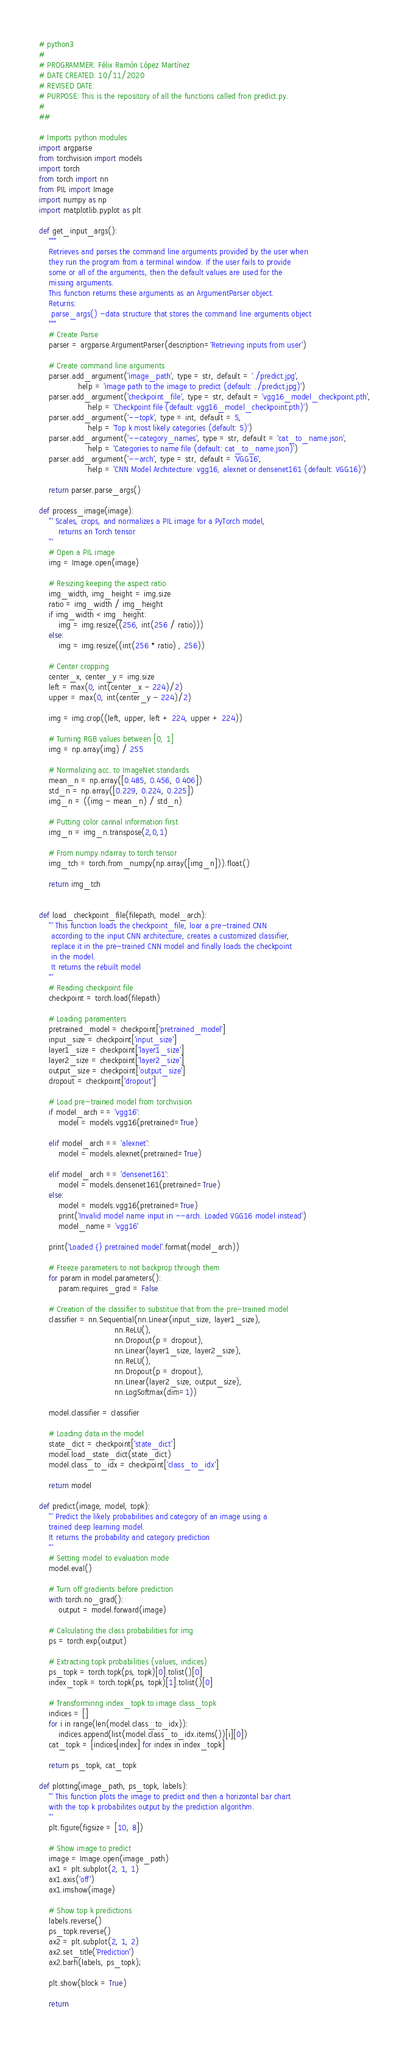Convert code to text. <code><loc_0><loc_0><loc_500><loc_500><_Python_># python3
#
# PROGRAMMER: Félix Ramón López Martínez
# DATE CREATED: 10/11/2020
# REVISED DATE:
# PURPOSE: This is the repository of all the functions called fron predict.py.
#
##

# Imports python modules
import argparse
from torchvision import models
import torch
from torch import nn
from PIL import Image
import numpy as np
import matplotlib.pyplot as plt

def get_input_args():
    """
    Retrieves and parses the command line arguments provided by the user when
    they run the program from a terminal window. If the user fails to provide
    some or all of the arguments, then the default values are used for the
    missing arguments.
    This function returns these arguments as an ArgumentParser object.
    Returns:
     parse_args() -data structure that stores the command line arguments object
    """
    # Create Parse
    parser = argparse.ArgumentParser(description='Retrieving inputs from user')

    # Create command line arguments
    parser.add_argument('image_path', type = str, default = './predict.jpg',
                help = 'image path to the image to predict (default: ./predict.jpg)')
    parser.add_argument('checkpoint_file', type = str, default = 'vgg16_model_checkpoint.pth',
                    help = 'Checkpoint file (default: vgg16_model_checkpoint.pth)')
    parser.add_argument('--topk', type = int, default = 5,
                    help = 'Top k most likely categories (default: 5)')
    parser.add_argument('--category_names', type = str, default = 'cat_to_name.json',
                    help = 'Categories to name file (default: cat_to_name.json)')
    parser.add_argument('--arch', type = str, default = 'VGG16',
                    help = 'CNN Model Architecture: vgg16, alexnet or densenet161 (default: VGG16)')

    return parser.parse_args()

def process_image(image):
    ''' Scales, crops, and normalizes a PIL image for a PyTorch model,
        returns an Torch tensor
    '''
    # Open a PIL image
    img = Image.open(image)

    # Resizing keeping the aspect ratio
    img_width, img_height = img.size
    ratio = img_width / img_height
    if img_width < img_height:
        img = img.resize((256, int(256 / ratio)))
    else:
        img = img.resize((int(256 * ratio) , 256))

    # Center cropping
    center_x, center_y = img.size
    left = max(0, int(center_x - 224)/2)
    upper = max(0, int(center_y - 224)/2)

    img = img.crop((left, upper, left + 224, upper + 224))

    # Turning RGB values between [0, 1]
    img = np.array(img) / 255

    # Normalizing acc. to ImageNet standards
    mean_n = np.array([0.485, 0.456, 0.406])
    std_n = np.array([0.229, 0.224, 0.225])
    img_n = ((img - mean_n) / std_n)

    # Putting color cannal information first
    img_n = img_n.transpose(2,0,1)

    # From numpy ndarray to torch tensor
    img_tch = torch.from_numpy(np.array([img_n])).float()

    return img_tch


def load_checkpoint_file(filepath, model_arch):
    ''' This function loads the checkpoint_file, loar a pre-trained CNN
     according to the input CNN architecture, creates a customized classifier,
     replace it in the pre-trained CNN model and finally loads the checkpoint
     in the model.
     It returns the rebuilt model
    '''
    # Reading checkpoint file
    checkpoint = torch.load(filepath)

    # Loading paramenters
    pretrained_model = checkpoint['pretrained_model']
    input_size = checkpoint['input_size']
    layer1_size = checkpoint['layer1_size']
    layer2_size = checkpoint['layer2_size']
    output_size = checkpoint['output_size']
    dropout = checkpoint['dropout']

    # Load pre-trained model from torchvision
    if model_arch == 'vgg16':
        model = models.vgg16(pretrained=True)

    elif model_arch == 'alexnet':
        model = models.alexnet(pretrained=True)

    elif model_arch == 'densenet161':
        model = models.densenet161(pretrained=True)
    else:
        model = models.vgg16(pretrained=True)
        print('Invalid model name input in --arch. Loaded VGG16 model instead')
        model_name = 'vgg16'

    print('Loaded {} pretrained model'.format(model_arch))

    # Freeze parameters to not backprop through them
    for param in model.parameters():
        param.requires_grad = False

    # Creation of the classifier to substitue that from the pre-trained model
    classifier = nn.Sequential(nn.Linear(input_size, layer1_size),
                               nn.ReLU(),
                               nn.Dropout(p = dropout),
                               nn.Linear(layer1_size, layer2_size),
                               nn.ReLU(),
                               nn.Dropout(p = dropout),
                               nn.Linear(layer2_size, output_size),
                               nn.LogSoftmax(dim=1))

    model.classifier = classifier

    # Loading data in the model
    state_dict = checkpoint['state_dict']
    model.load_state_dict(state_dict)
    model.class_to_idx = checkpoint['class_to_idx']

    return model

def predict(image, model, topk):
    ''' Predict the likely probabilities and category of an image using a
    trained deep learning model.
    It returns the probability and category prediction
    '''
    # Setting model to evaluation mode
    model.eval()

    # Turn off gradients before prediction
    with torch.no_grad():
        output = model.forward(image)

    # Calculating the class probabilities for img
    ps = torch.exp(output)

    # Extracting topk probabilities (values, indices)
    ps_topk = torch.topk(ps, topk)[0].tolist()[0]
    index_topk = torch.topk(ps, topk)[1].tolist()[0]

    # Transforminng index_topk to image class_topk
    indices = []
    for i in range(len(model.class_to_idx)):
        indices.append(list(model.class_to_idx.items())[i][0])
    cat_topk = [indices[index] for index in index_topk]

    return ps_topk, cat_topk

def plotting(image_path, ps_topk, labels):
    ''' This function plots the image to predict and then a horizontal bar chart
    with the top k probabilites output by the prediction algorithm.
    '''
    plt.figure(figsize = [10, 8])

    # Show image to predict
    image = Image.open(image_path)
    ax1 = plt.subplot(2, 1, 1)
    ax1.axis('off')
    ax1.imshow(image)

    # Show top k predictions
    labels.reverse()
    ps_topk.reverse()
    ax2 = plt.subplot(2, 1, 2)
    ax2.set_title('Prediction')
    ax2.barh(labels, ps_topk);

    plt.show(block = True)

    return
</code> 